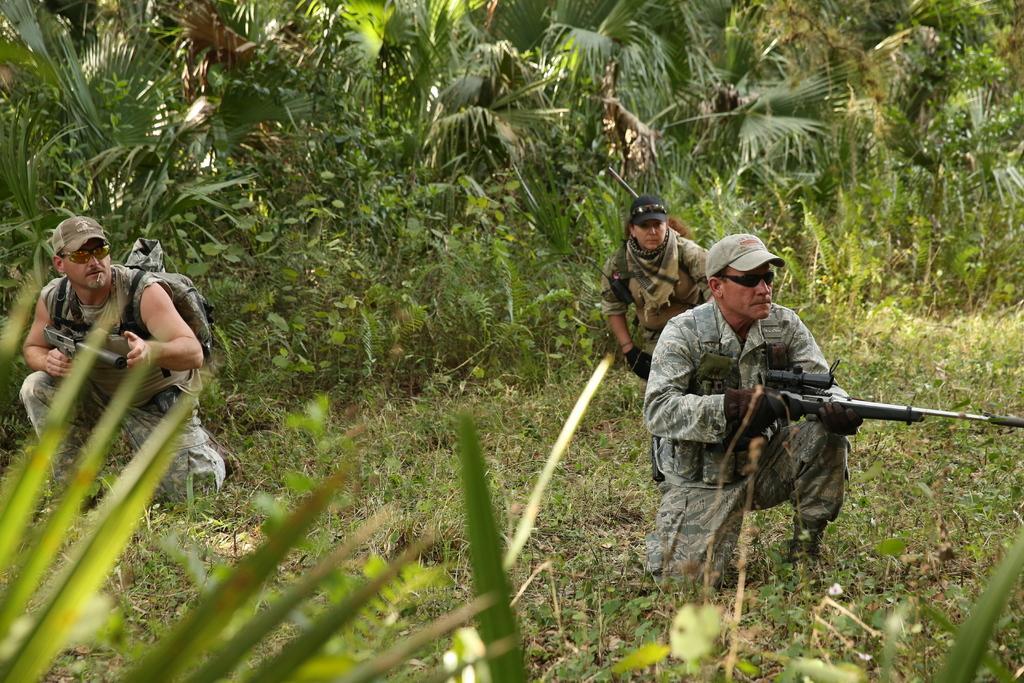How would you summarize this image in a sentence or two? In this image we can see people holding rifles in their hands and we can also see trees, plants and grass. 